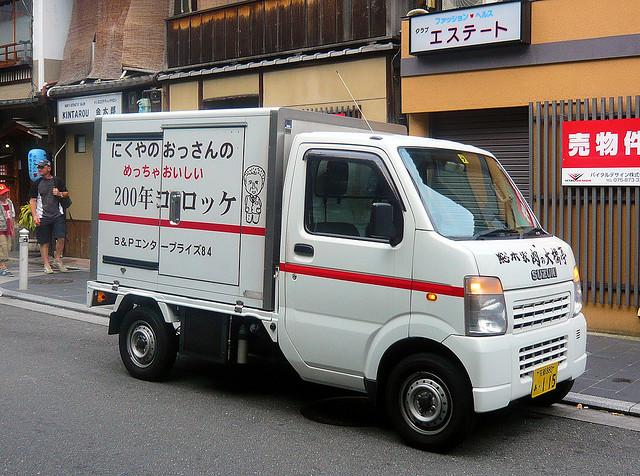What temperature items might be carried by this truck? cold 